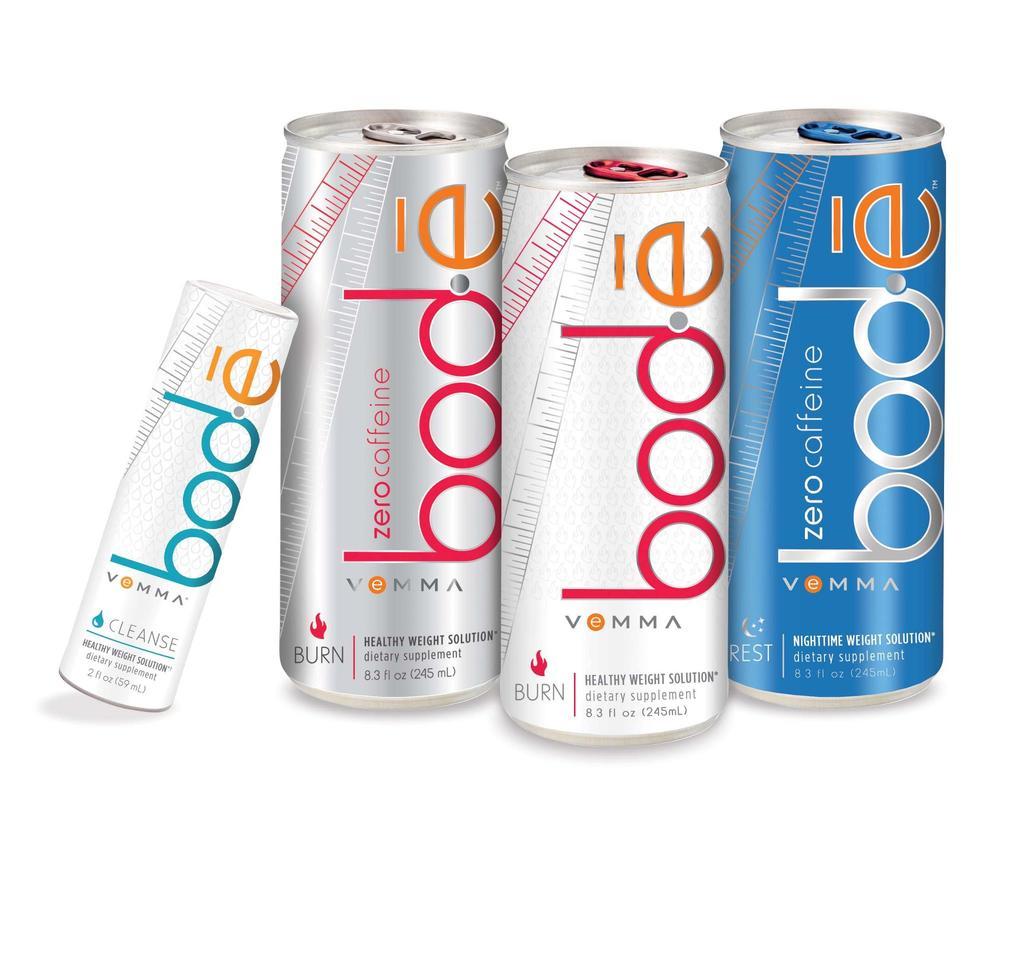How many fluid ounces are in this can?
Ensure brevity in your answer.  8.3. 